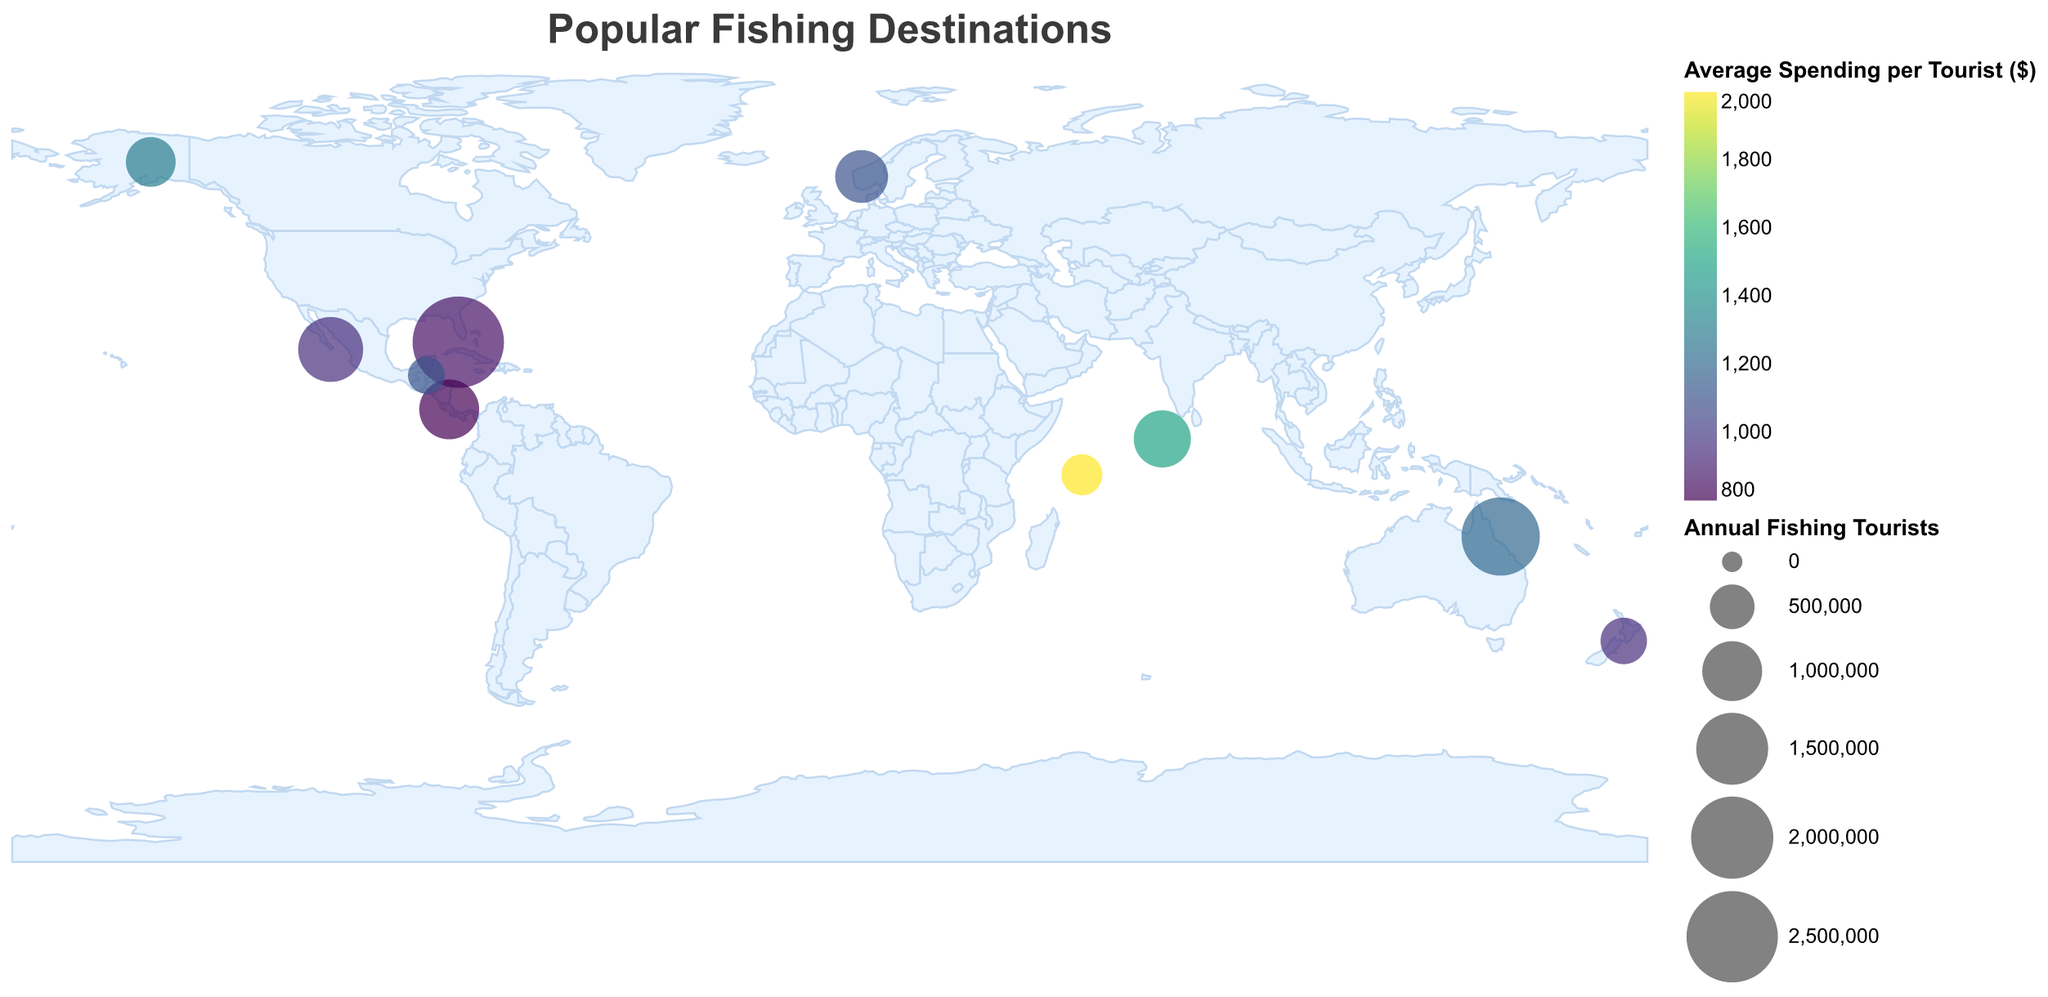What is the title of the figure? The title is displayed prominently at the top of the figure in a larger font size and reads "Popular Fishing Destinations."
Answer: Popular Fishing Destinations How many data points represent the fishing destinations in the figure? By visually inspecting the figure, we can count the number of circles representing fishing destinations. Each circle corresponds to a data point.
Answer: 10 Which region has the highest number of annual fishing tourists? Look for the largest circle in the figure, as the size of the circle represents the number of annual fishing tourists. The largest circle is in the Florida Keys region.
Answer: Florida Keys Which region has the highest average spending per tourist? The color intensity represents the average spending per tourist, with darker colors indicating higher spending. The darkest circle is in the Seychelles region.
Answer: Seychelles What is the total number of annual fishing tourists for all regions combined? Sum the values of the "Annual Fishing Tourists" for all the listed regions: 2,500,000 (Florida Keys) + 1,800,000 (Great Barrier Reef) + 1,200,000 (Cabo San Lucas) + 900,000 (Maldives) + 750,000 (Norway Fjords) + 1,000,000 (Costa Rica) + 650,000 (Alaska) + 400,000 (Seychelles) + 550,000 (New Zealand) + 300,000 (Belize).
Answer: 10,050,000 Which region shows the least average spending per tourist, and what is the amount? The lightest-colored circle represents the least average spending per tourist. The lightest circle is in the Costa Rica region, with a value of $800.
Answer: Costa Rica, $800 How does the number of annual fishing tourists in Cabo San Lucas compare to that in Costa Rica? Compare the size of the circles for Cabo San Lucas and Costa Rica. Cabo San Lucas has 1,200,000 tourists, and Costa Rica has 1,000,000 tourists.
Answer: Cabo San Lucas has more tourists Which regions are located in the Southern Hemisphere? Identify the regions whose latitude values are negative or closer to the equator and south. These regions are the Great Barrier Reef, Maldives, Seychelles, and New Zealand.
Answer: Great Barrier Reef, Maldives, Seychelles, New Zealand What is the average spending per tourist across all regions? Calculate the average by summing the "Average Spending per Tourist ($)" for all regions and then dividing by the number of regions. Sum: 850 + 1200 + 950 + 1500 + 1100 + 800 + 1300 + 2000 + 950 + 1100 = 11650. Divide by 10 regions: 11650 / 10 = 1165.
Answer: $1165 